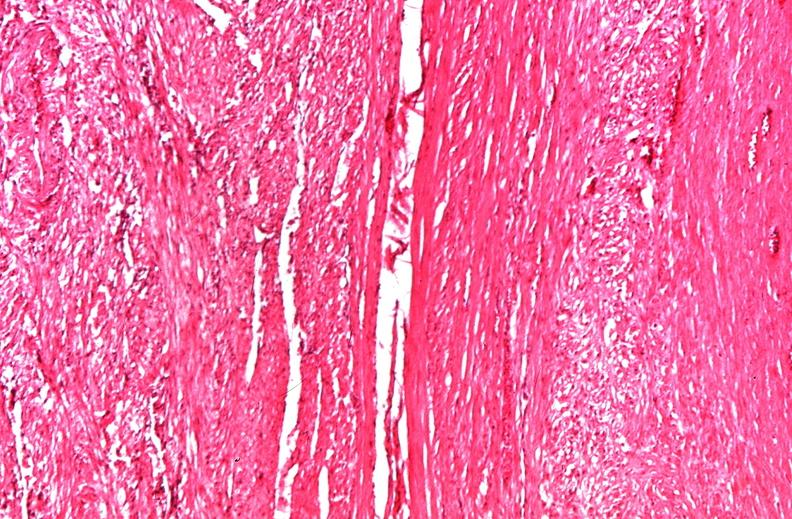does fibrinous peritonitis show uterus, leiomyomas?
Answer the question using a single word or phrase. No 